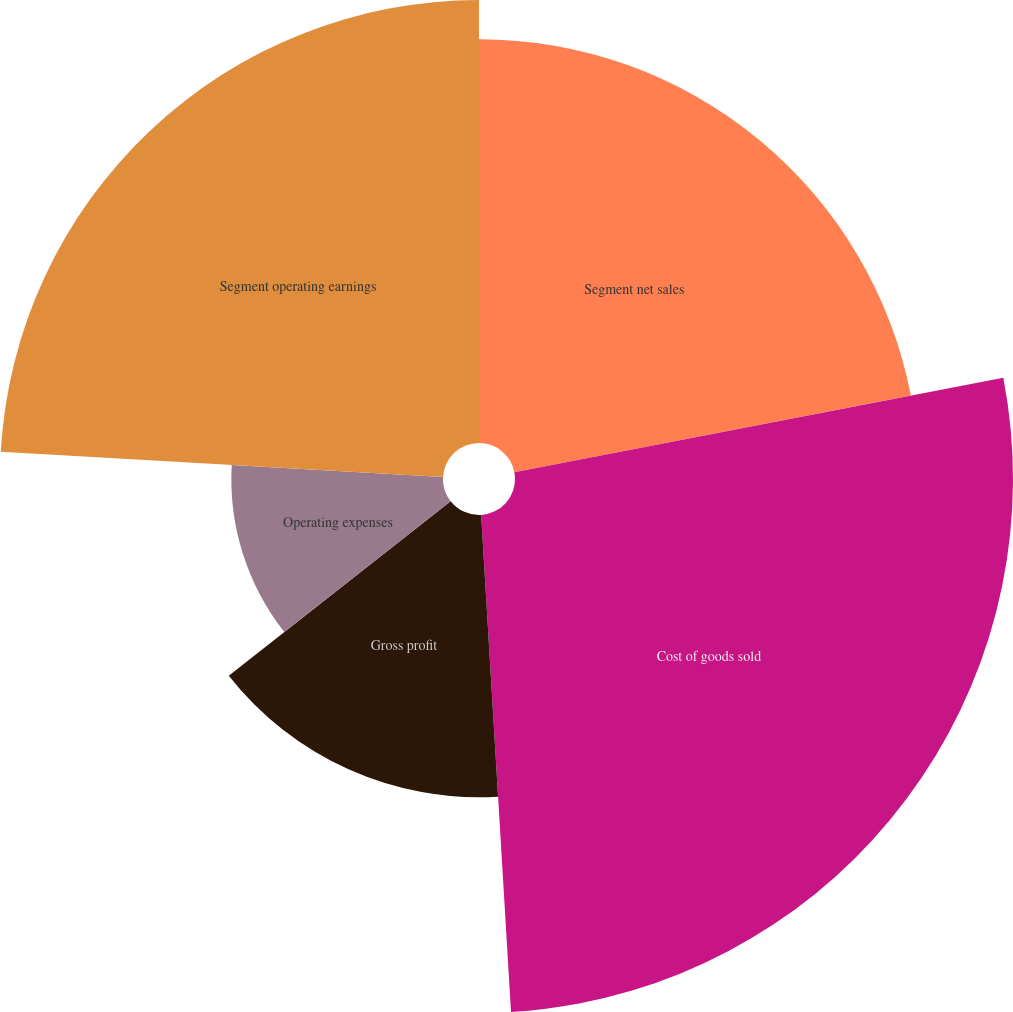Convert chart to OTSL. <chart><loc_0><loc_0><loc_500><loc_500><pie_chart><fcel>Segment net sales<fcel>Cost of goods sold<fcel>Gross profit<fcel>Operating expenses<fcel>Segment operating earnings<nl><fcel>21.96%<fcel>27.08%<fcel>15.35%<fcel>11.51%<fcel>24.09%<nl></chart> 